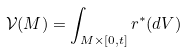Convert formula to latex. <formula><loc_0><loc_0><loc_500><loc_500>\mathcal { V } ( M ) = \int _ { M \times [ 0 , t ] } r ^ { * } ( d V )</formula> 